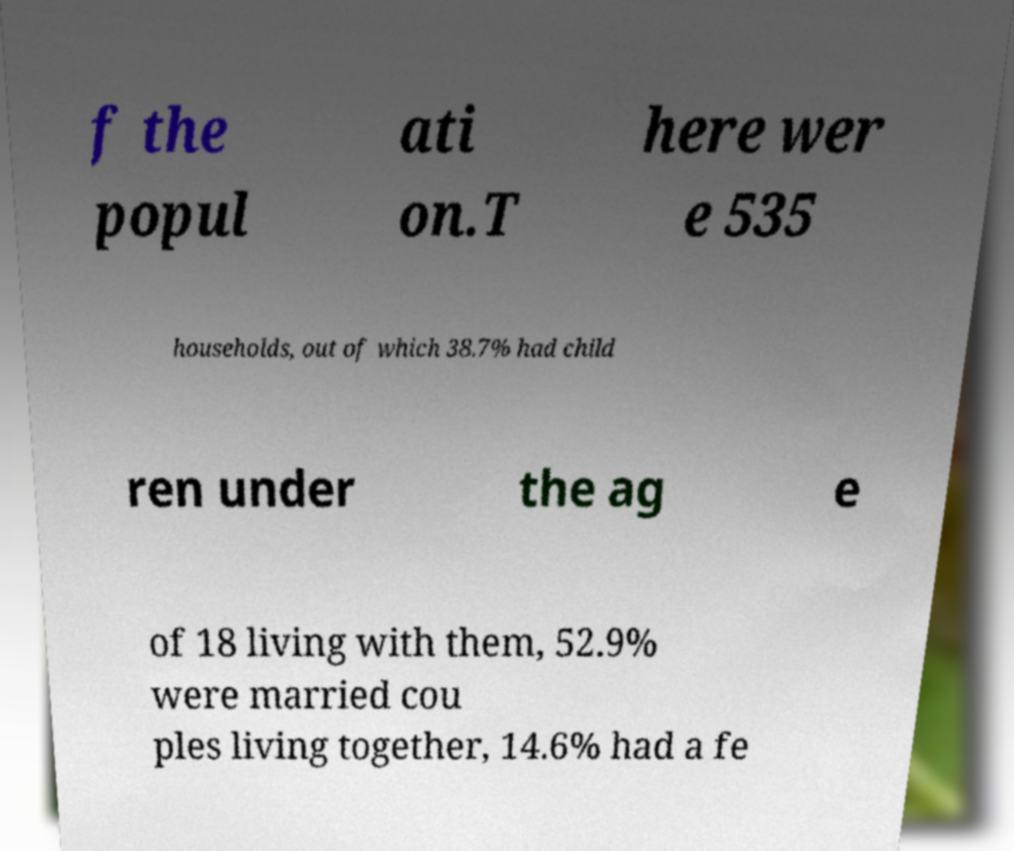Could you extract and type out the text from this image? f the popul ati on.T here wer e 535 households, out of which 38.7% had child ren under the ag e of 18 living with them, 52.9% were married cou ples living together, 14.6% had a fe 